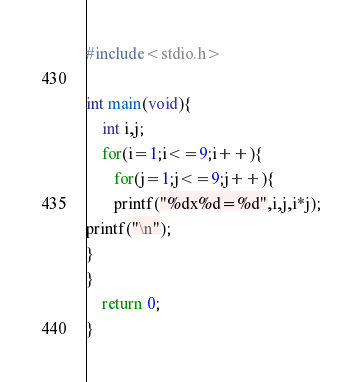<code> <loc_0><loc_0><loc_500><loc_500><_C_>#include<stdio.h>

int main(void){
    int i,j;
    for(i=1;i<=9;i++){
       for(j=1;j<=9;j++){
       printf("%dx%d=%d",i,j,i*j);
printf("\n");
}
}
    return 0;
}</code> 